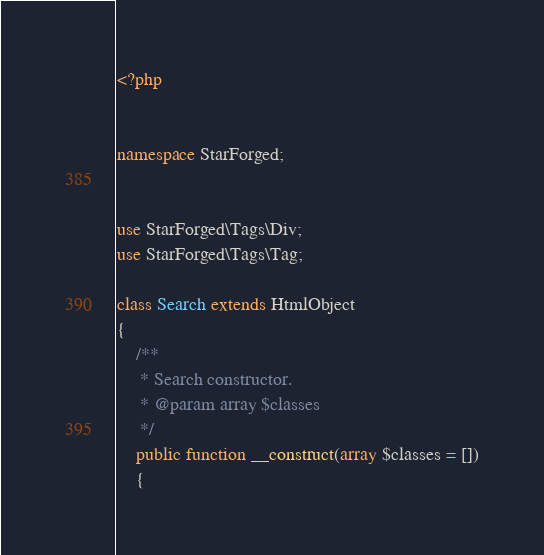Convert code to text. <code><loc_0><loc_0><loc_500><loc_500><_PHP_><?php


namespace StarForged;


use StarForged\Tags\Div;
use StarForged\Tags\Tag;

class Search extends HtmlObject
{
    /**
     * Search constructor.
     * @param array $classes
     */
    public function __construct(array $classes = [])
    {</code> 